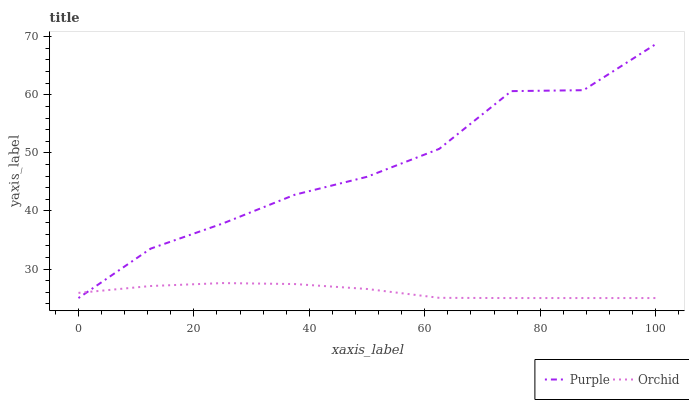Does Orchid have the minimum area under the curve?
Answer yes or no. Yes. Does Purple have the maximum area under the curve?
Answer yes or no. Yes. Does Orchid have the maximum area under the curve?
Answer yes or no. No. Is Orchid the smoothest?
Answer yes or no. Yes. Is Purple the roughest?
Answer yes or no. Yes. Is Orchid the roughest?
Answer yes or no. No. Does Purple have the lowest value?
Answer yes or no. Yes. Does Purple have the highest value?
Answer yes or no. Yes. Does Orchid have the highest value?
Answer yes or no. No. Does Orchid intersect Purple?
Answer yes or no. Yes. Is Orchid less than Purple?
Answer yes or no. No. Is Orchid greater than Purple?
Answer yes or no. No. 